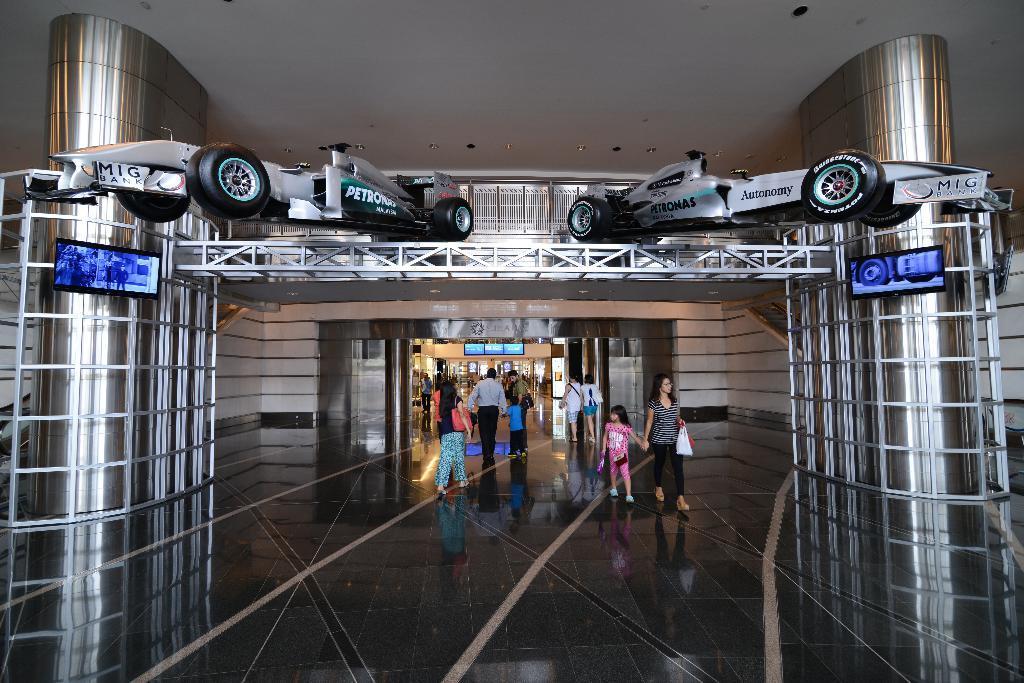Can you describe this image briefly? In this there is an entrance of a shopping mall, people are walking in the center, on either side of the entrance there are two pillars, for that pillar there is an iron frame at the top there are cars, on above that there is a ceiling and lights. 